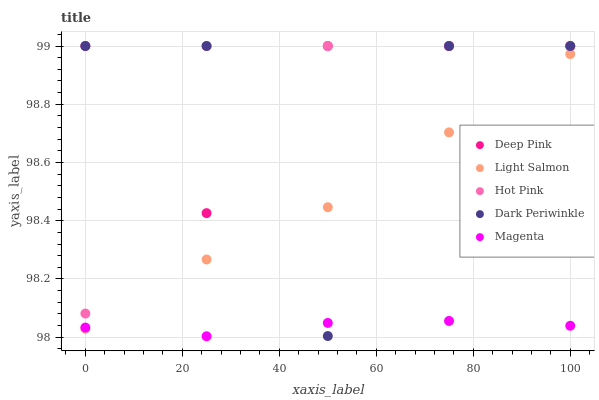Does Magenta have the minimum area under the curve?
Answer yes or no. Yes. Does Hot Pink have the maximum area under the curve?
Answer yes or no. Yes. Does Deep Pink have the minimum area under the curve?
Answer yes or no. No. Does Deep Pink have the maximum area under the curve?
Answer yes or no. No. Is Magenta the smoothest?
Answer yes or no. Yes. Is Dark Periwinkle the roughest?
Answer yes or no. Yes. Is Deep Pink the smoothest?
Answer yes or no. No. Is Deep Pink the roughest?
Answer yes or no. No. Does Magenta have the lowest value?
Answer yes or no. Yes. Does Dark Periwinkle have the lowest value?
Answer yes or no. No. Does Hot Pink have the highest value?
Answer yes or no. Yes. Does Magenta have the highest value?
Answer yes or no. No. Is Magenta less than Deep Pink?
Answer yes or no. Yes. Is Hot Pink greater than Magenta?
Answer yes or no. Yes. Does Dark Periwinkle intersect Light Salmon?
Answer yes or no. Yes. Is Dark Periwinkle less than Light Salmon?
Answer yes or no. No. Is Dark Periwinkle greater than Light Salmon?
Answer yes or no. No. Does Magenta intersect Deep Pink?
Answer yes or no. No. 